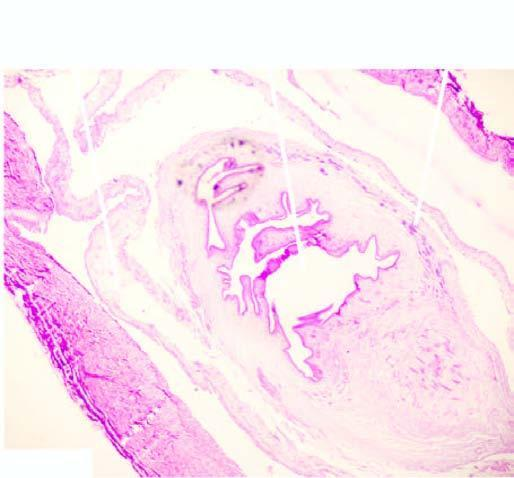does the cyst wall show palisade layer of histiocytes?
Answer the question using a single word or phrase. Yes 